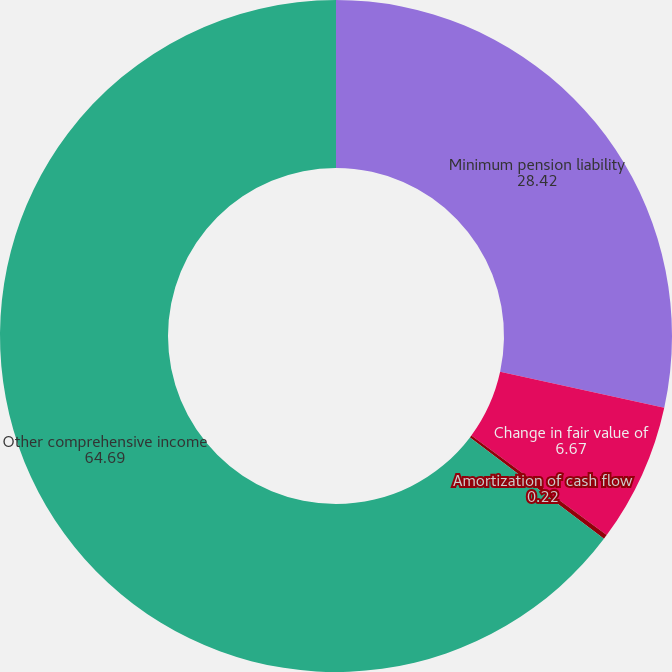Convert chart to OTSL. <chart><loc_0><loc_0><loc_500><loc_500><pie_chart><fcel>Minimum pension liability<fcel>Change in fair value of<fcel>Amortization of cash flow<fcel>Other comprehensive income<nl><fcel>28.42%<fcel>6.67%<fcel>0.22%<fcel>64.69%<nl></chart> 